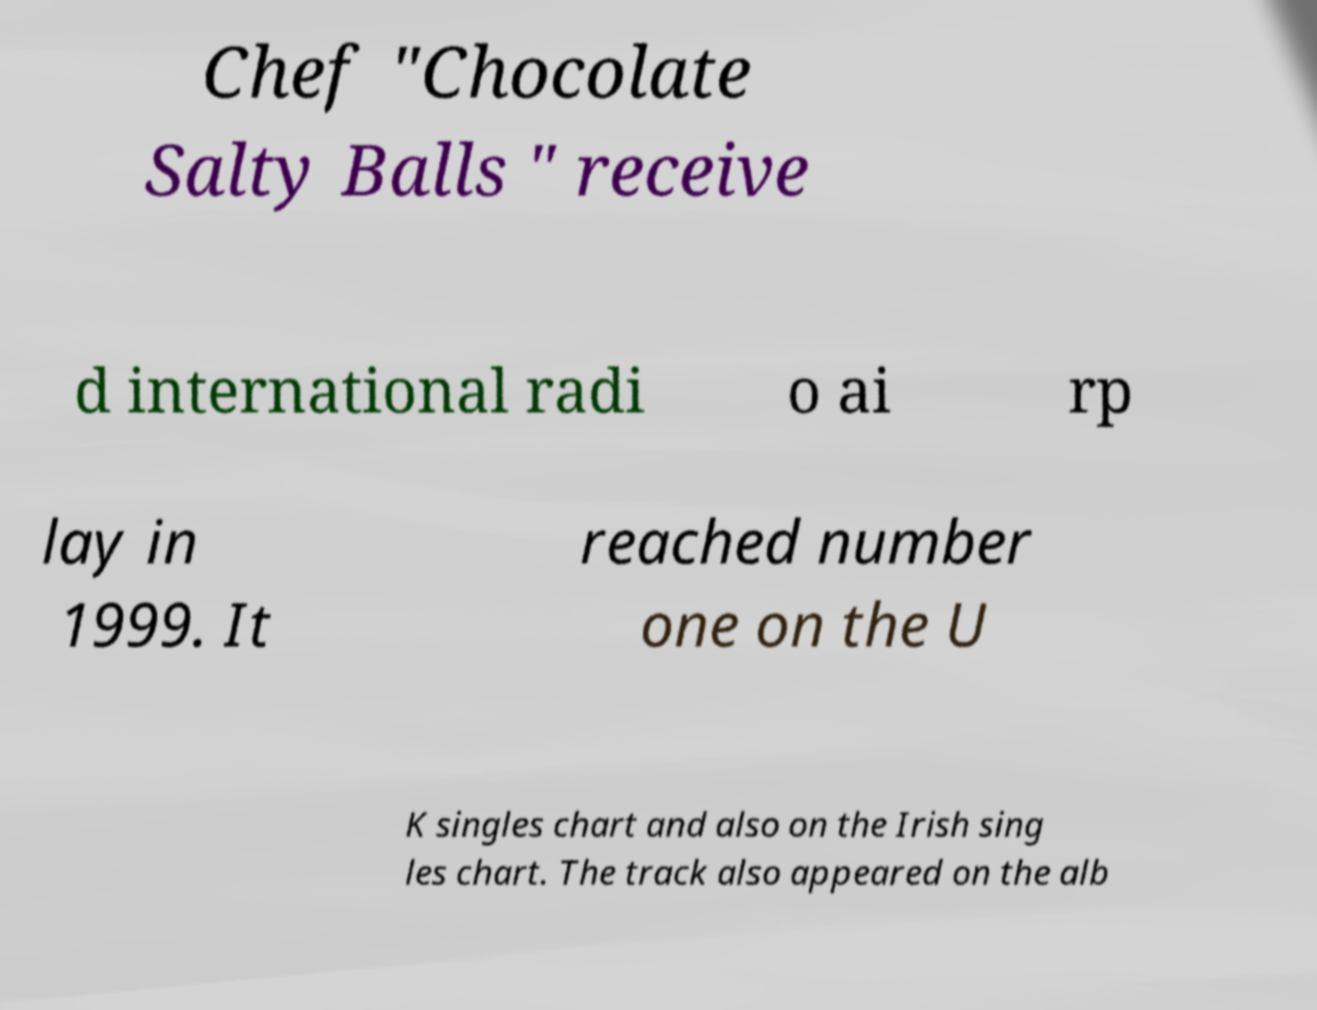Can you read and provide the text displayed in the image?This photo seems to have some interesting text. Can you extract and type it out for me? Chef "Chocolate Salty Balls " receive d international radi o ai rp lay in 1999. It reached number one on the U K singles chart and also on the Irish sing les chart. The track also appeared on the alb 